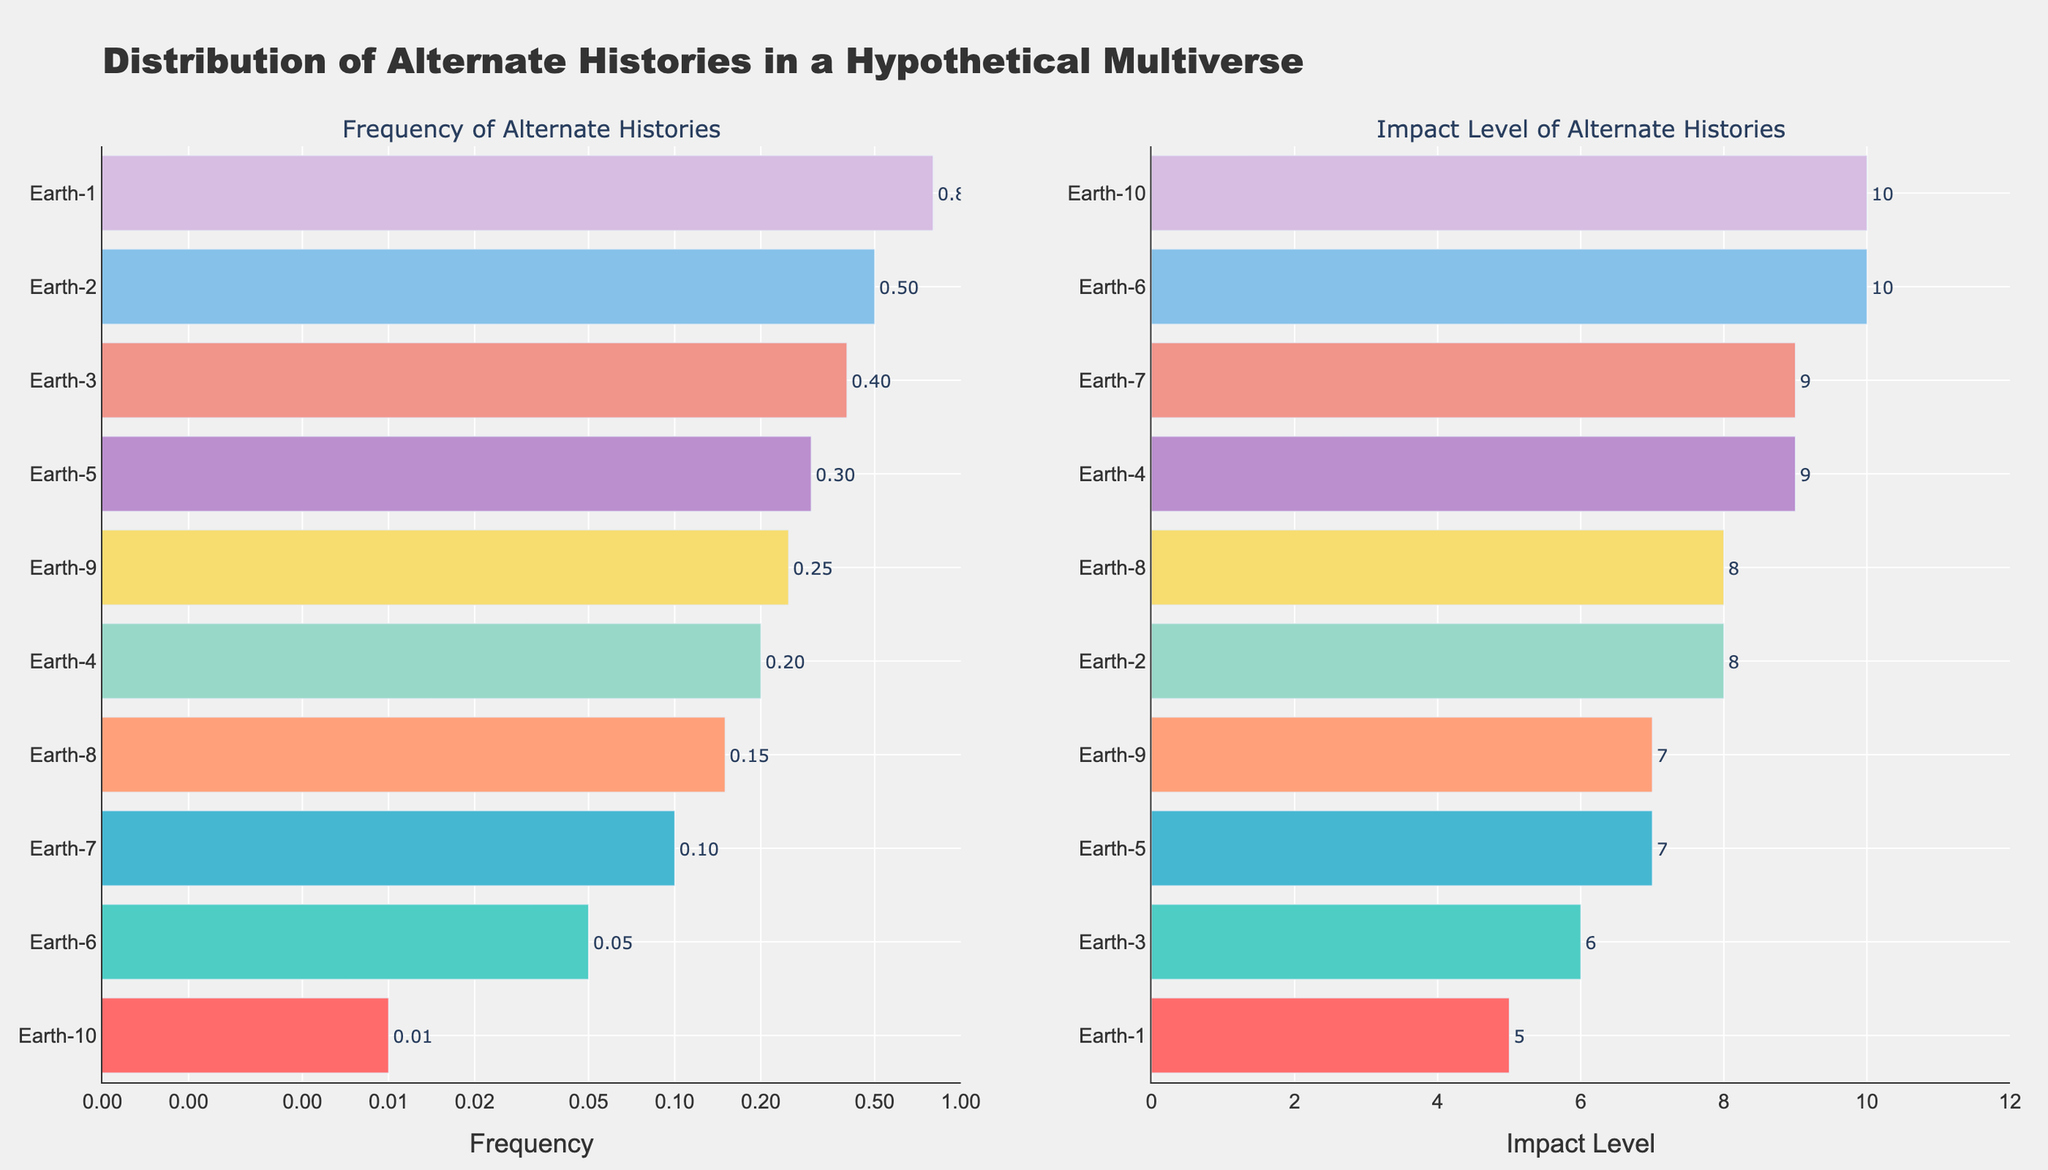What is the title of the plot? The title is displayed at the top of the figure, which reads "Distribution of Alternate Histories in a Hypothetical Multiverse".
Answer: Distribution of Alternate Histories in a Hypothetical Multiverse Which axis uses a log scale? The x-axis of the subplot on the left (Frequency of Alternate Histories) uses a log scale.
Answer: The x-axis of the Frequency subplot What is the frequency of the artificial intelligence development in the 19th century? The artificial intelligence development in the 19th century corresponds to Earth-10, which has a Frequency value of 0.01 according to its bar position on the left subplot.
Answer: 0.01 How many alternate histories have an impact level of 9 or higher? From the right subplot, we identify the bars with an impact level of 9 or higher. These bars correspond to Earth-4, Earth-6, and Earth-7.
Answer: 3 Which alternate history has the highest impact level? The alternate history with the highest impact level is Earth-6: Successful Space Colony in the 20th Century, with an impact level of 10, as seen from the right subplot.
Answer: Successful Space Colony in the 20th Century What is the impact level difference between "Napoleon Conquers Russia" and "Dinosaurs Survive Extinction"? From the right subplot, "Napoleon Conquers Russia" has an impact level of 7, and "Dinosaurs Survive Extinction" has an impact level of 9. The difference is 9 - 7 = 2.
Answer: 2 Which alternate history has the lowest frequency and what is its impact level? The bar with the lowest frequency (left subplot) represents Earth-10: Artificial Intelligence Developed in the 19th Century, with an impact level of 10 according to the right subplot.
Answer: Earth-10, Impact Level: 10 How does the impact level of "Industrial Revolution in China" compare to that of "Ancient Egyptian Technological Ascendancy"? The right subplot shows that "Industrial Revolution in China" has an impact level of 6, while "Ancient Egyptian Technological Ascendancy" has an impact level of 8. Therefore, "Ancient Egyptian Technological Ascendancy" has a higher impact level.
Answer: Ancient Egyptian Technological Ascendancy has a higher impact level What is the median frequency of the alternate histories displayed on the Frequency subplot? To find the median, we order the frequencies: 0.01, 0.05, 0.1, 0.15, 0.2, 0.25, 0.3, 0.4, 0.5, 0.8. The middle value (average of 0.2 and 0.25) is (0.2 + 0.25) / 2 = 0.225.
Answer: 0.225 